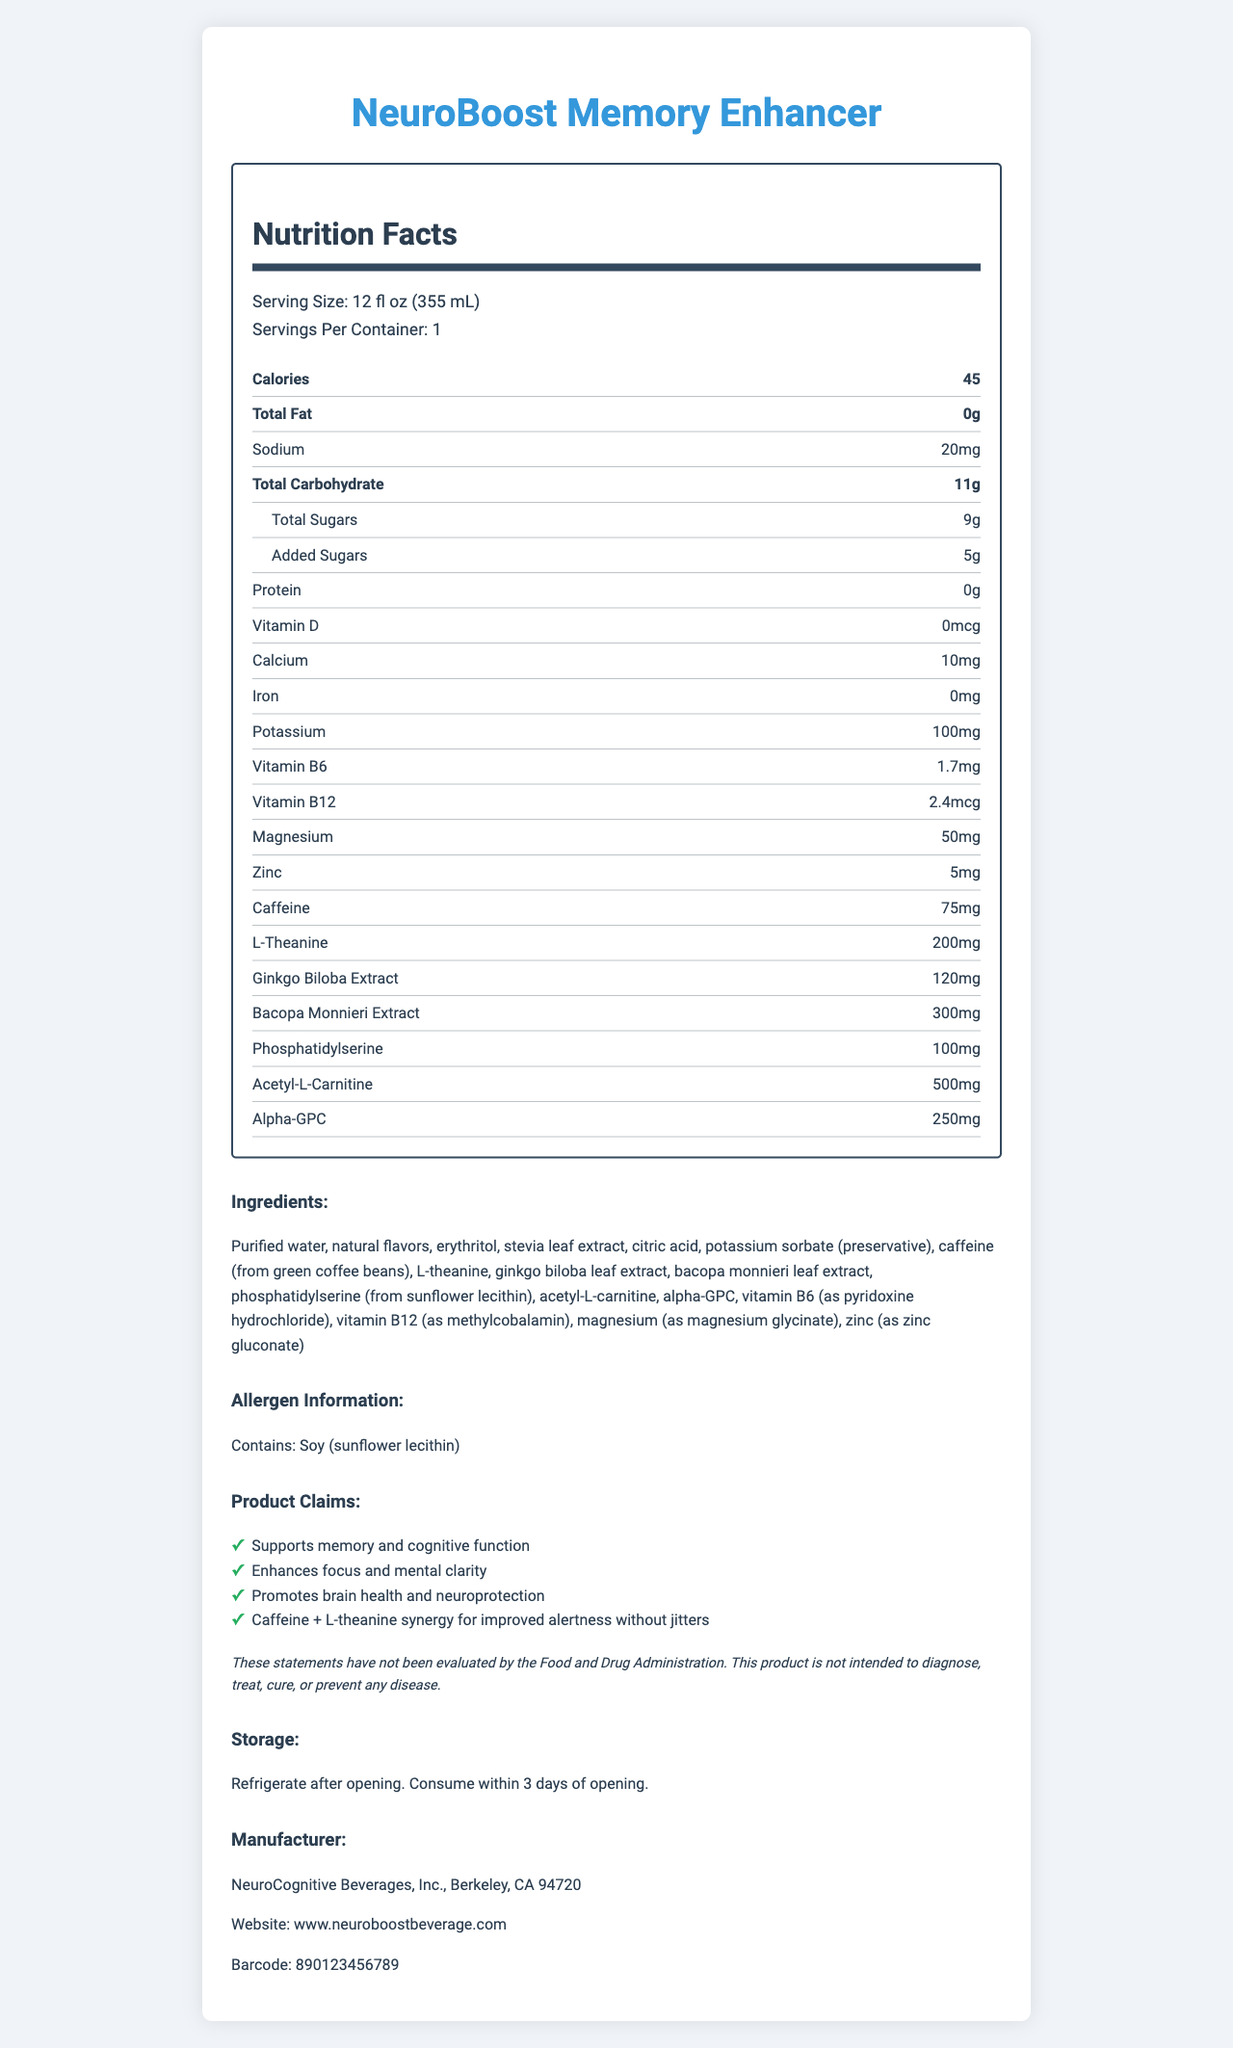what is the serving size of NeuroBoost Memory Enhancer? The serving size is stated at the top under "Serving Size".
Answer: 12 fl oz (355 mL) how many servings are there per container? The document clearly states "Servings Per Container: 1".
Answer: 1 how many calories are in one serving? The "Calories" section indicates that there are 45 calories per serving.
Answer: 45 what is the total amount of carbohydrates in one serving? The "Total Carbohydrate" section reports that there are 11 grams of total carbohydrates.
Answer: 11g how much caffeine does NeuroBoost Memory Enhancer contain? The "Caffeine" values are given as 75mg in the nutritional information.
Answer: 75mg which type of preservative is used in the NeuroBoost Memory Enhancer? The ingredients list includes potassium sorbate as a preservative.
Answer: Potassium sorbate what is the amount of L-Theanine per serving? The nutritional information specifies that there is 200mg of L-Theanine.
Answer: 200mg what allergens does the NeuroBoost Memory Enhancer contain? The allergen information highlights that the product contains soy, derived from sunflower lecithin.
Answer: Soy (sunflower lecithin) Summarize the main claims made by NeuroBoost Memory Enhancer. These claims are listed in the "Product Claims" section.
Answer: Supports memory and cognitive function, enhances focus and mental clarity, promotes brain health and neuroprotection, and offers caffeine + L-theanine synergy for improved alertness without jitters. Is the product intended to diagnose, treat, cure, or prevent any disease? The disclaimer explicitly states that the product is not intended to diagnose, treat, cure, or prevent any disease.
Answer: No how much Vitamin B6 is in the product? The nutritional information specifies 1.7mg of Vitamin B6.
Answer: 1.7mg what is the website for NeuroBoost Memory Enhancer? The website is listed under the manufacturer information.
Answer: www.neuroboostbeverage.com which city is NeuroCognitive Beverages, Inc. located in? The manufacturer section states that the company is located in Berkeley, CA 94720.
Answer: Berkeley, CA 94720 Which of the following is NOT an ingredient in the NeuroBoost Memory Enhancer? A. Purified water B. Sodium chloride C. Erythritol D. Stevia leaf extract Sodium chloride is not listed in the ingredients.
Answer: B How many grams of added sugars does the product contain? A. 3g B. 5g C. 7g D. 9g The nutritional information indicates that there are 5 grams of added sugars.
Answer: B Does NeuroBoost Memory Enhancer contain iron? Yes/No The nutritional information shows "Iron: 0mg".
Answer: No What is the primary purpose of adding phosphatidylserine to the beverage? While phosphatidylserine is listed as an ingredient and is known for cognitive benefits, its primary purpose within the specific context of this product isn't explicitly stated in the document.
Answer: Cannot be determined What is the barcode number of NeuroBoost Memory Enhancer? The barcode number is provided in the manufacturer section.
Answer: 890123456789 